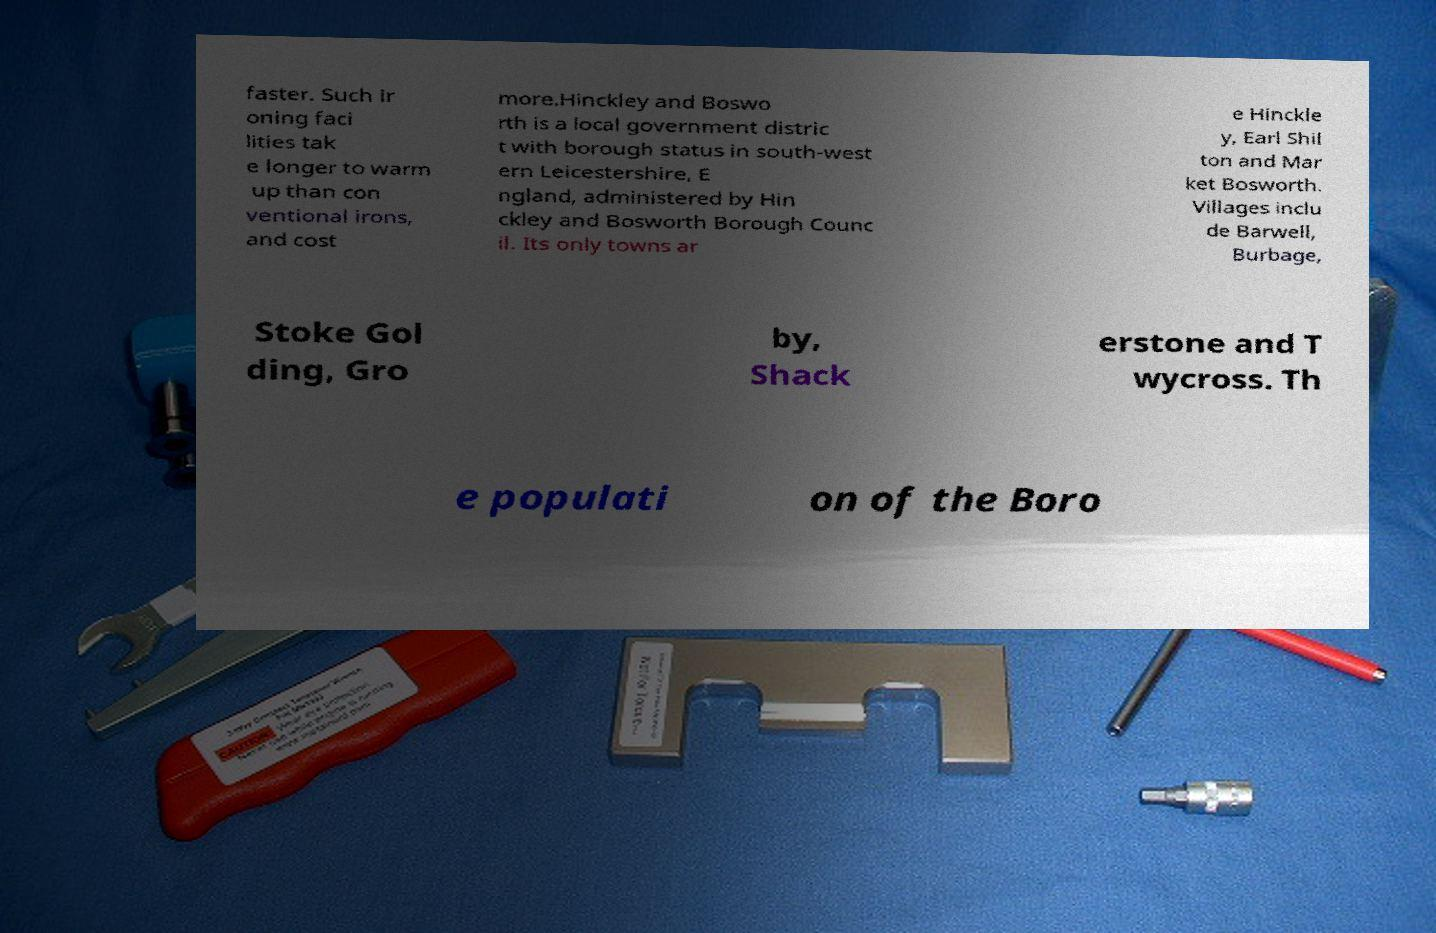There's text embedded in this image that I need extracted. Can you transcribe it verbatim? faster. Such ir oning faci lities tak e longer to warm up than con ventional irons, and cost more.Hinckley and Boswo rth is a local government distric t with borough status in south-west ern Leicestershire, E ngland, administered by Hin ckley and Bosworth Borough Counc il. Its only towns ar e Hinckle y, Earl Shil ton and Mar ket Bosworth. Villages inclu de Barwell, Burbage, Stoke Gol ding, Gro by, Shack erstone and T wycross. Th e populati on of the Boro 